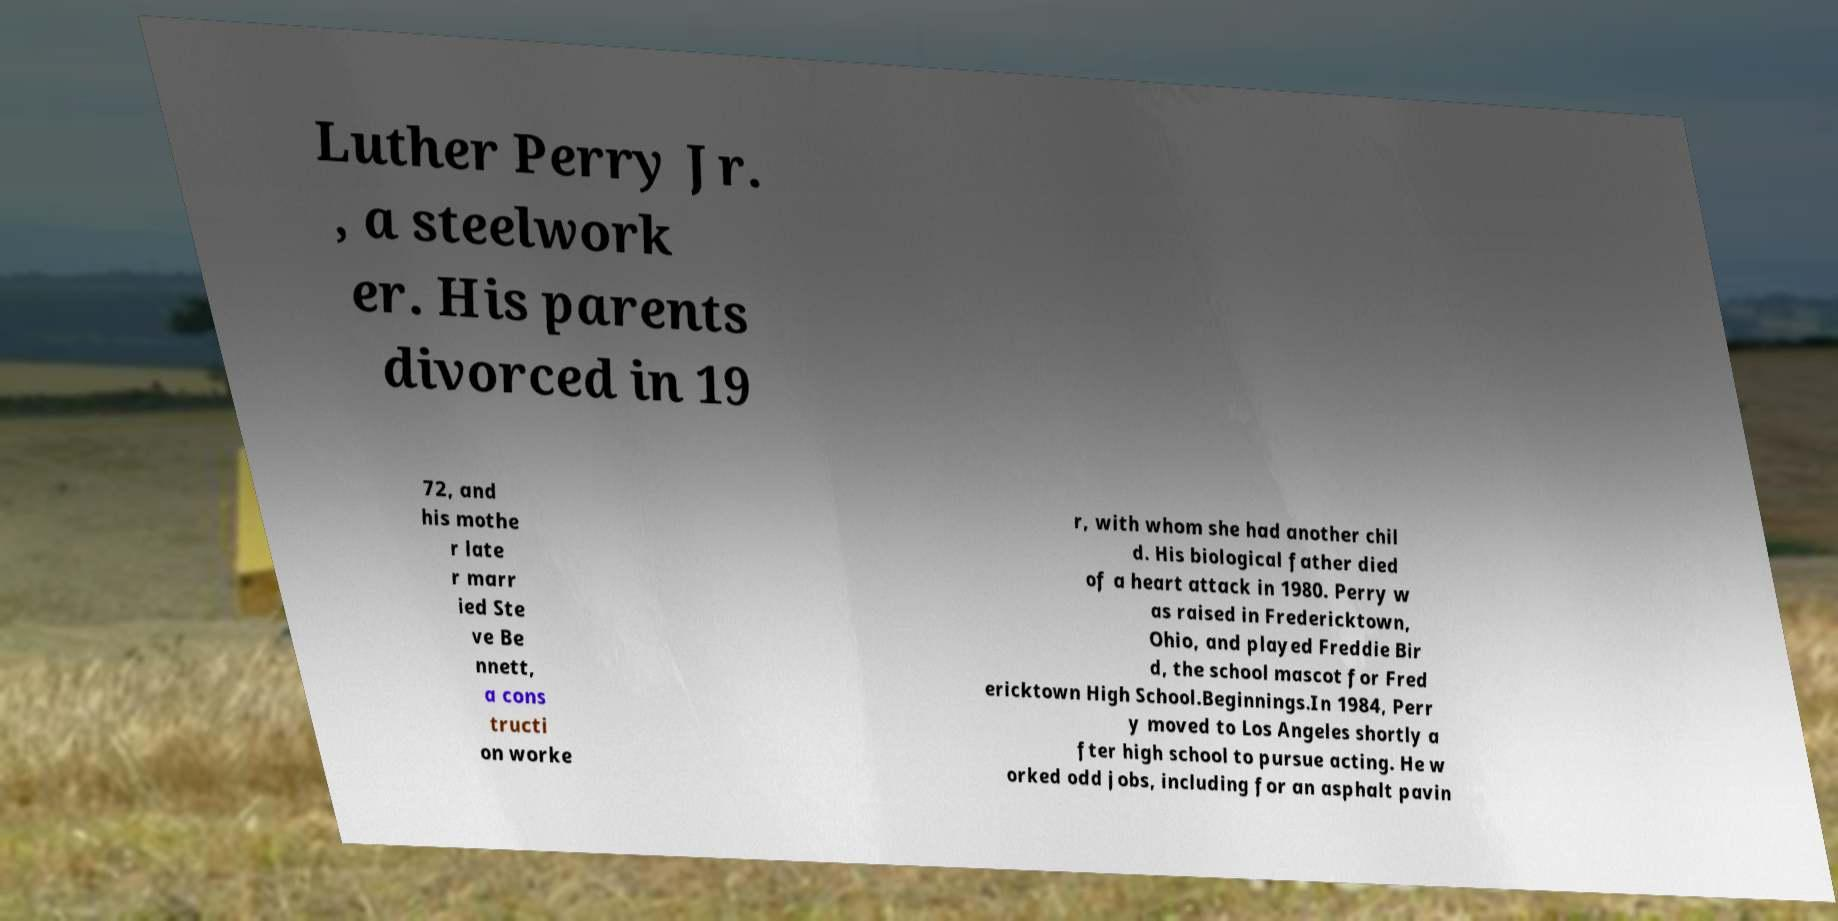There's text embedded in this image that I need extracted. Can you transcribe it verbatim? Luther Perry Jr. , a steelwork er. His parents divorced in 19 72, and his mothe r late r marr ied Ste ve Be nnett, a cons tructi on worke r, with whom she had another chil d. His biological father died of a heart attack in 1980. Perry w as raised in Fredericktown, Ohio, and played Freddie Bir d, the school mascot for Fred ericktown High School.Beginnings.In 1984, Perr y moved to Los Angeles shortly a fter high school to pursue acting. He w orked odd jobs, including for an asphalt pavin 